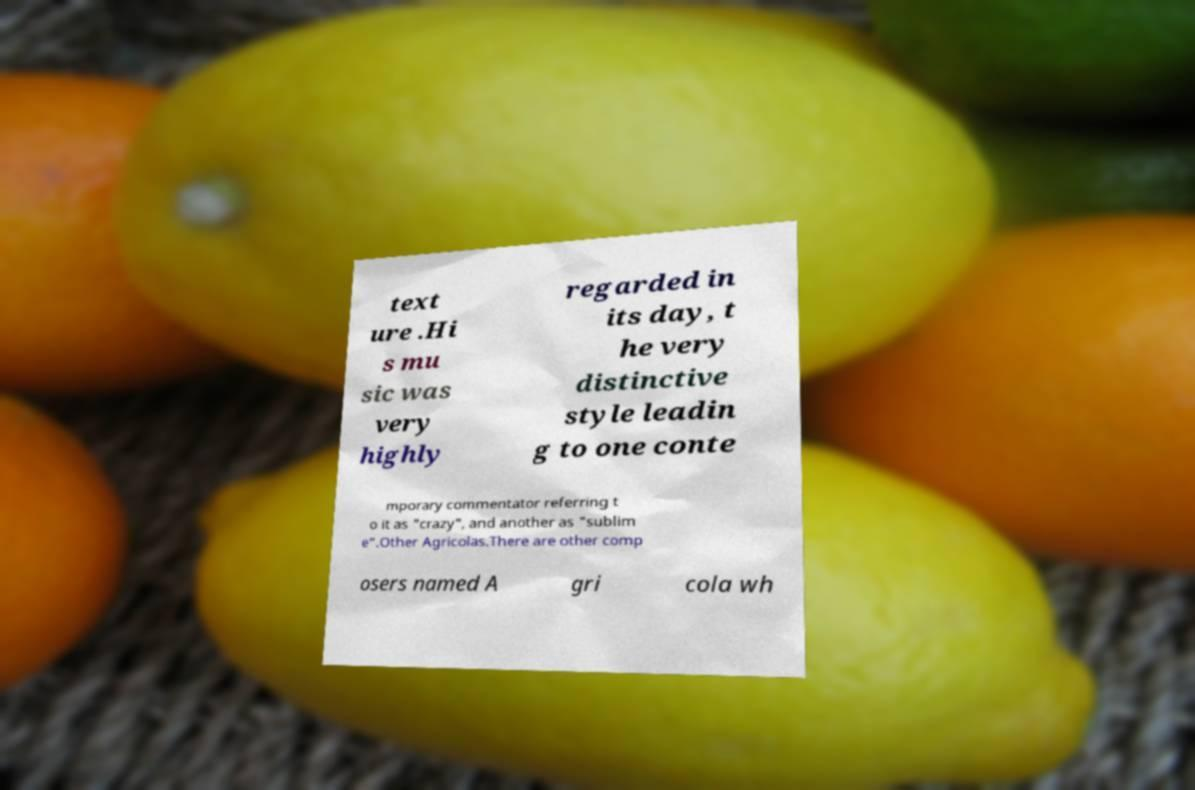What messages or text are displayed in this image? I need them in a readable, typed format. text ure .Hi s mu sic was very highly regarded in its day, t he very distinctive style leadin g to one conte mporary commentator referring t o it as "crazy", and another as "sublim e".Other Agricolas.There are other comp osers named A gri cola wh 